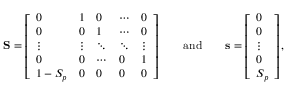Convert formula to latex. <formula><loc_0><loc_0><loc_500><loc_500>S = \left [ \begin{array} { l l l l l } { 0 } & { 1 } & { 0 } & { \cdots } & { 0 } \\ { 0 } & { 0 } & { 1 } & { \cdots } & { 0 } \\ { \vdots } & { \vdots } & { \ddots } & { \ddots } & { \vdots } \\ { 0 } & { 0 } & { \cdots } & { 0 } & { 1 } \\ { 1 - S _ { p } } & { 0 } & { 0 } & { 0 } & { 0 } \end{array} \right ] \quad a n d \quad s = \left [ \begin{array} { l } { 0 } \\ { 0 } \\ { \vdots } \\ { 0 } \\ { S _ { p } } \end{array} \right ] ,</formula> 